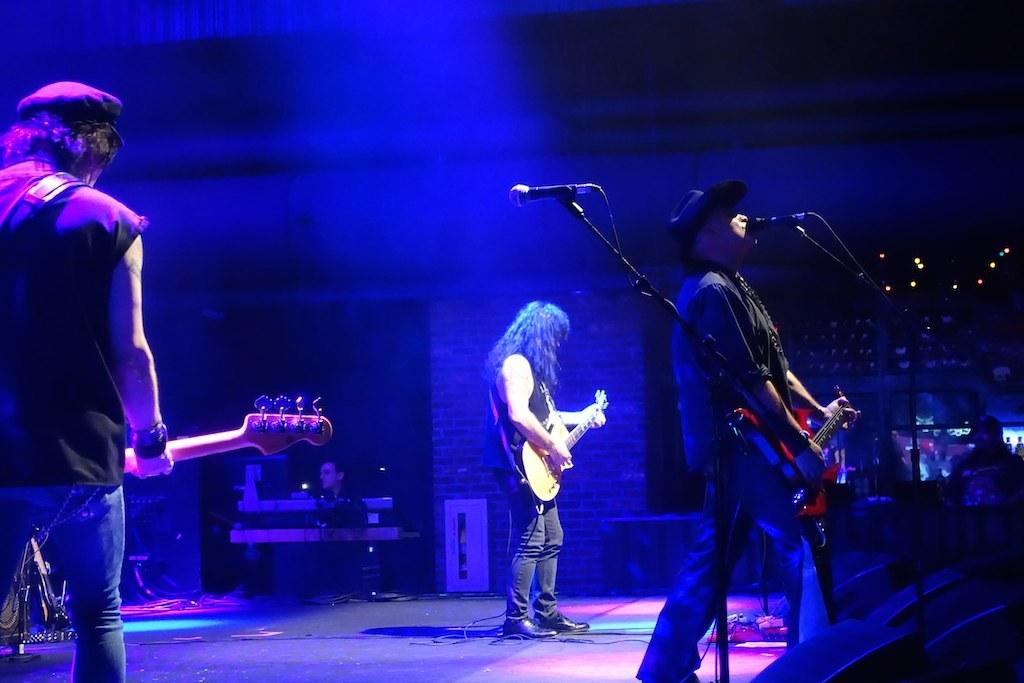What is the main subject of the image? The main subject of the image is a group of people. What are the three people in front of microphones doing? The three people are playing guitar. What can be seen at the bottom of the image? There are wires and speakers at the bottom of the image. How many sisters are visible in the image? There is no mention of sisters in the image, so we cannot determine the number of sisters present. What type of care is being provided to the nest in the image? There is no nest present in the image, so we cannot discuss any care being provided to it. 